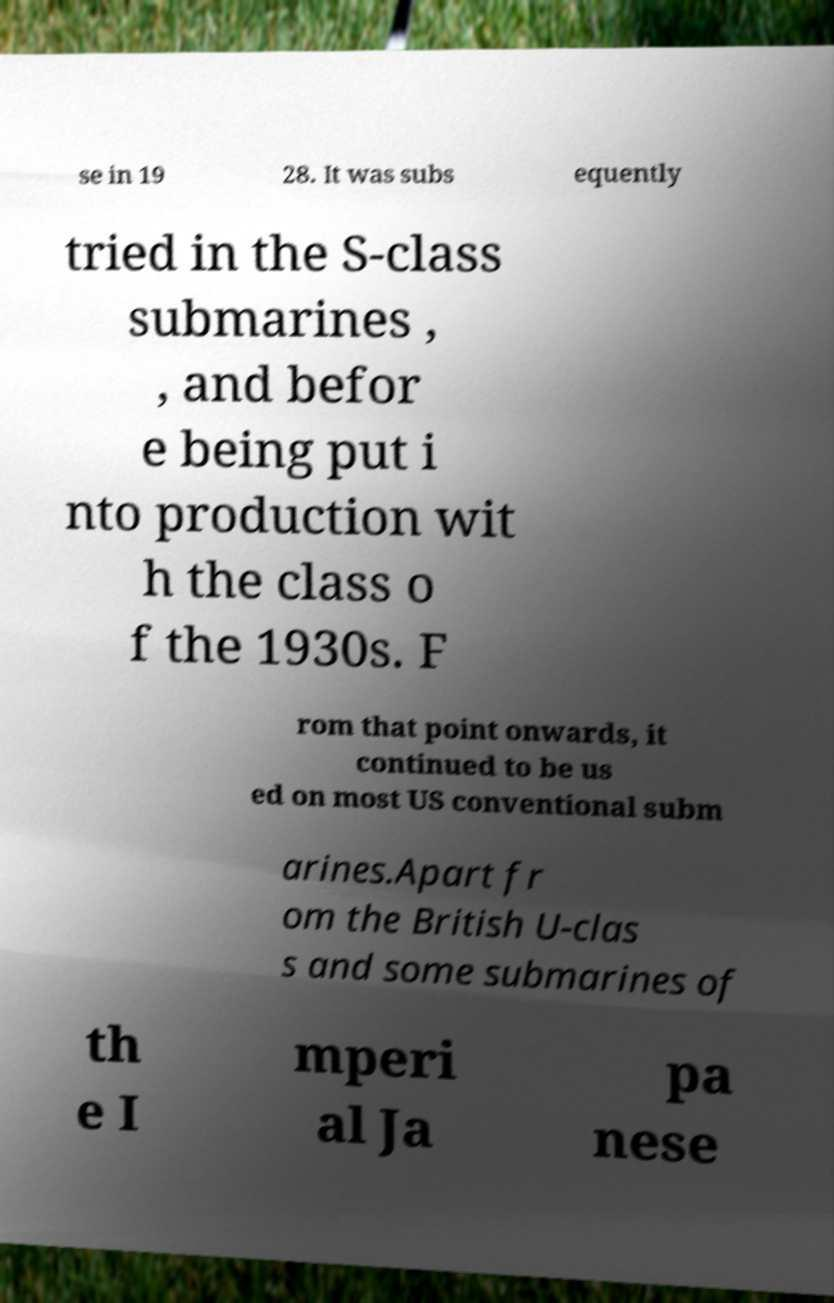There's text embedded in this image that I need extracted. Can you transcribe it verbatim? se in 19 28. It was subs equently tried in the S-class submarines , , and befor e being put i nto production wit h the class o f the 1930s. F rom that point onwards, it continued to be us ed on most US conventional subm arines.Apart fr om the British U-clas s and some submarines of th e I mperi al Ja pa nese 